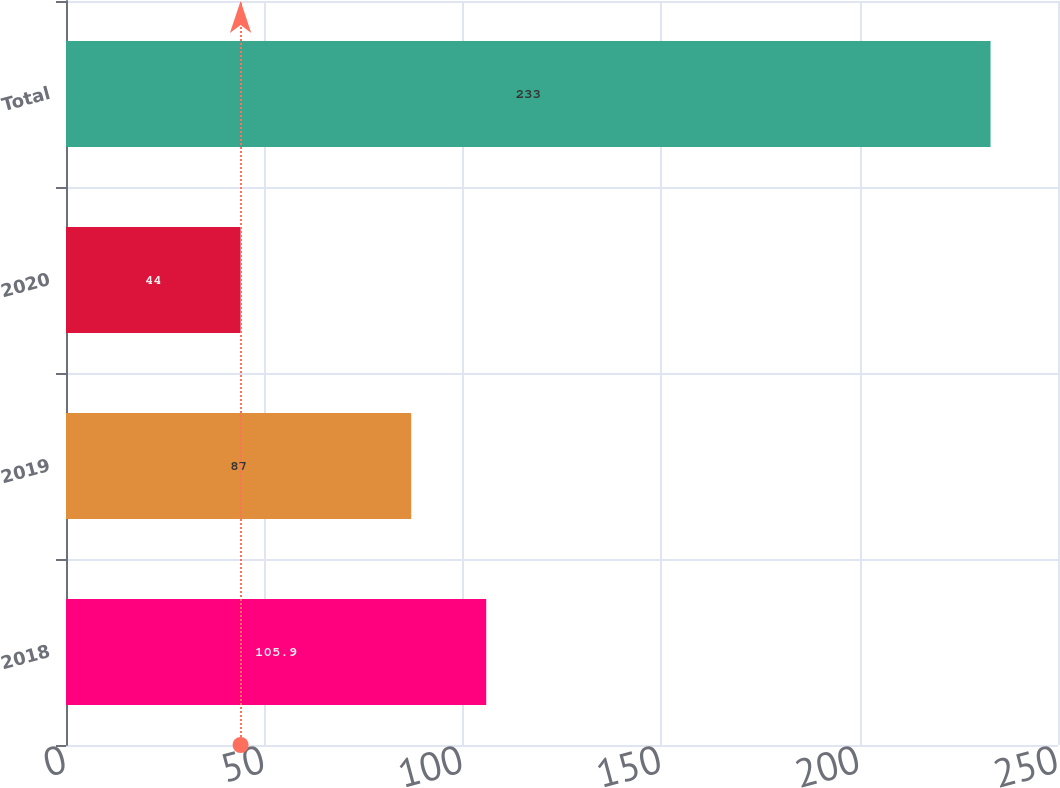<chart> <loc_0><loc_0><loc_500><loc_500><bar_chart><fcel>2018<fcel>2019<fcel>2020<fcel>Total<nl><fcel>105.9<fcel>87<fcel>44<fcel>233<nl></chart> 